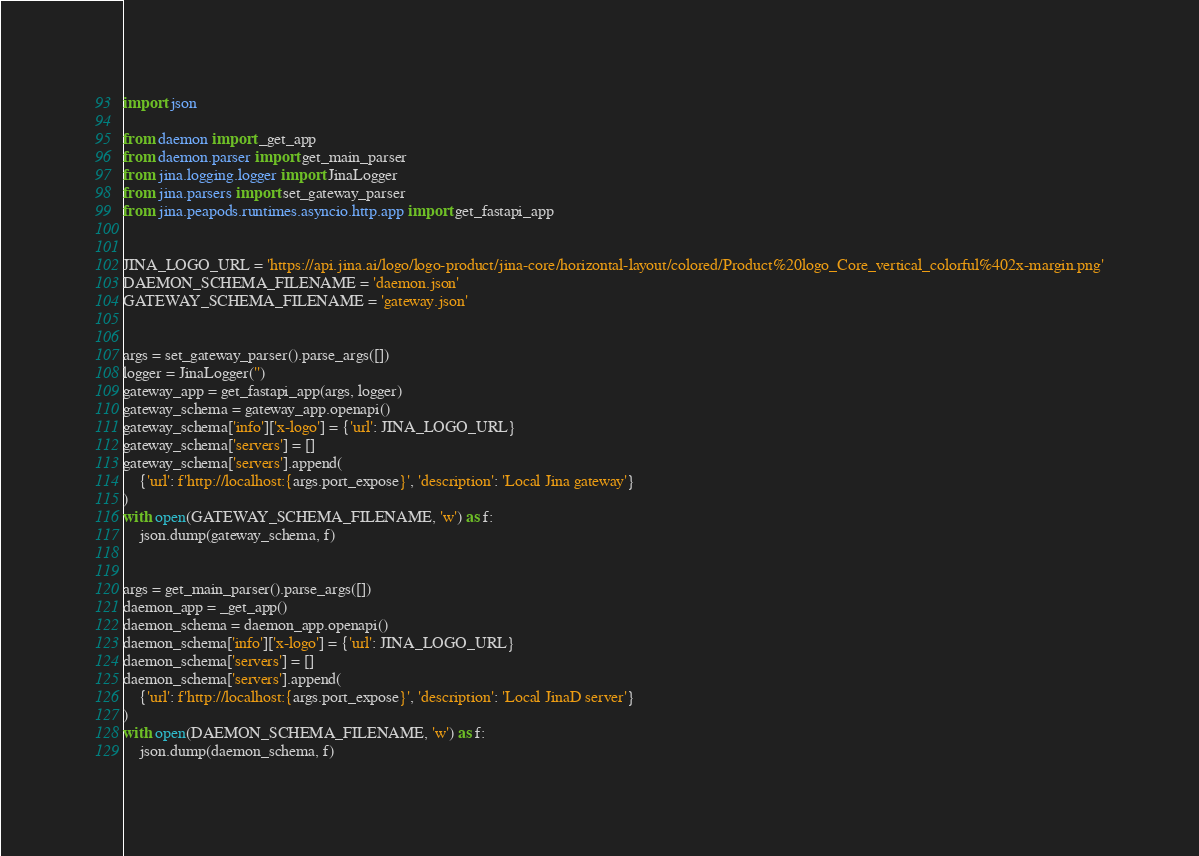Convert code to text. <code><loc_0><loc_0><loc_500><loc_500><_Python_>import json

from daemon import _get_app
from daemon.parser import get_main_parser
from jina.logging.logger import JinaLogger
from jina.parsers import set_gateway_parser
from jina.peapods.runtimes.asyncio.http.app import get_fastapi_app


JINA_LOGO_URL = 'https://api.jina.ai/logo/logo-product/jina-core/horizontal-layout/colored/Product%20logo_Core_vertical_colorful%402x-margin.png'
DAEMON_SCHEMA_FILENAME = 'daemon.json'
GATEWAY_SCHEMA_FILENAME = 'gateway.json'


args = set_gateway_parser().parse_args([])
logger = JinaLogger('')
gateway_app = get_fastapi_app(args, logger)
gateway_schema = gateway_app.openapi()
gateway_schema['info']['x-logo'] = {'url': JINA_LOGO_URL}
gateway_schema['servers'] = []
gateway_schema['servers'].append(
    {'url': f'http://localhost:{args.port_expose}', 'description': 'Local Jina gateway'}
)
with open(GATEWAY_SCHEMA_FILENAME, 'w') as f:
    json.dump(gateway_schema, f)


args = get_main_parser().parse_args([])
daemon_app = _get_app()
daemon_schema = daemon_app.openapi()
daemon_schema['info']['x-logo'] = {'url': JINA_LOGO_URL}
daemon_schema['servers'] = []
daemon_schema['servers'].append(
    {'url': f'http://localhost:{args.port_expose}', 'description': 'Local JinaD server'}
)
with open(DAEMON_SCHEMA_FILENAME, 'w') as f:
    json.dump(daemon_schema, f)
</code> 